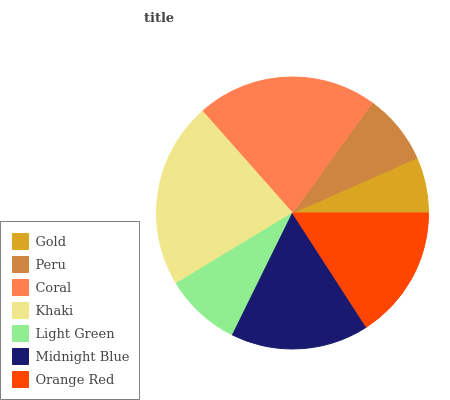Is Gold the minimum?
Answer yes or no. Yes. Is Khaki the maximum?
Answer yes or no. Yes. Is Peru the minimum?
Answer yes or no. No. Is Peru the maximum?
Answer yes or no. No. Is Peru greater than Gold?
Answer yes or no. Yes. Is Gold less than Peru?
Answer yes or no. Yes. Is Gold greater than Peru?
Answer yes or no. No. Is Peru less than Gold?
Answer yes or no. No. Is Orange Red the high median?
Answer yes or no. Yes. Is Orange Red the low median?
Answer yes or no. Yes. Is Gold the high median?
Answer yes or no. No. Is Khaki the low median?
Answer yes or no. No. 